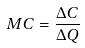<formula> <loc_0><loc_0><loc_500><loc_500>M C = \frac { \Delta C } { \Delta Q }</formula> 